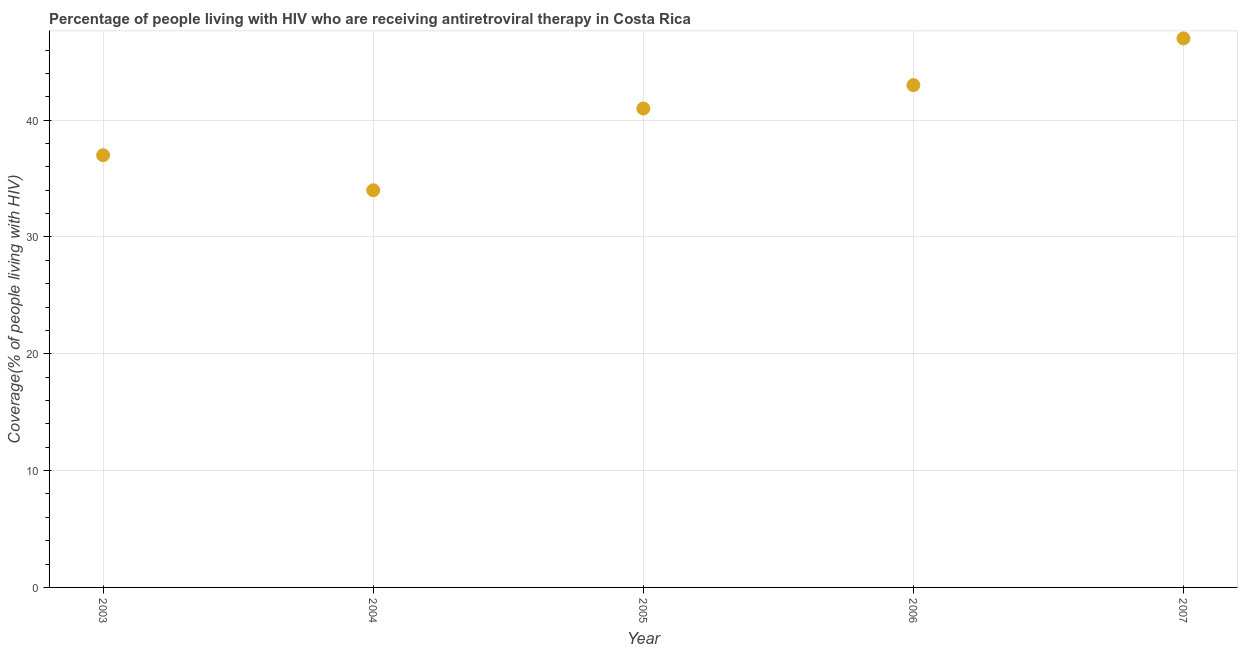What is the antiretroviral therapy coverage in 2004?
Offer a very short reply. 34. Across all years, what is the maximum antiretroviral therapy coverage?
Your answer should be very brief. 47. Across all years, what is the minimum antiretroviral therapy coverage?
Keep it short and to the point. 34. In which year was the antiretroviral therapy coverage maximum?
Offer a very short reply. 2007. In which year was the antiretroviral therapy coverage minimum?
Give a very brief answer. 2004. What is the sum of the antiretroviral therapy coverage?
Ensure brevity in your answer.  202. What is the difference between the antiretroviral therapy coverage in 2006 and 2007?
Keep it short and to the point. -4. What is the average antiretroviral therapy coverage per year?
Offer a terse response. 40.4. What is the ratio of the antiretroviral therapy coverage in 2006 to that in 2007?
Your response must be concise. 0.91. Is the antiretroviral therapy coverage in 2006 less than that in 2007?
Ensure brevity in your answer.  Yes. What is the difference between the highest and the lowest antiretroviral therapy coverage?
Your answer should be compact. 13. How many dotlines are there?
Keep it short and to the point. 1. What is the difference between two consecutive major ticks on the Y-axis?
Give a very brief answer. 10. Does the graph contain grids?
Keep it short and to the point. Yes. What is the title of the graph?
Offer a very short reply. Percentage of people living with HIV who are receiving antiretroviral therapy in Costa Rica. What is the label or title of the X-axis?
Your answer should be compact. Year. What is the label or title of the Y-axis?
Give a very brief answer. Coverage(% of people living with HIV). What is the Coverage(% of people living with HIV) in 2004?
Your answer should be compact. 34. What is the Coverage(% of people living with HIV) in 2005?
Provide a succinct answer. 41. What is the Coverage(% of people living with HIV) in 2007?
Provide a succinct answer. 47. What is the difference between the Coverage(% of people living with HIV) in 2003 and 2006?
Provide a succinct answer. -6. What is the difference between the Coverage(% of people living with HIV) in 2003 and 2007?
Provide a succinct answer. -10. What is the difference between the Coverage(% of people living with HIV) in 2004 and 2005?
Your answer should be very brief. -7. What is the difference between the Coverage(% of people living with HIV) in 2005 and 2007?
Your answer should be very brief. -6. What is the ratio of the Coverage(% of people living with HIV) in 2003 to that in 2004?
Your answer should be compact. 1.09. What is the ratio of the Coverage(% of people living with HIV) in 2003 to that in 2005?
Your response must be concise. 0.9. What is the ratio of the Coverage(% of people living with HIV) in 2003 to that in 2006?
Provide a succinct answer. 0.86. What is the ratio of the Coverage(% of people living with HIV) in 2003 to that in 2007?
Ensure brevity in your answer.  0.79. What is the ratio of the Coverage(% of people living with HIV) in 2004 to that in 2005?
Offer a terse response. 0.83. What is the ratio of the Coverage(% of people living with HIV) in 2004 to that in 2006?
Your answer should be compact. 0.79. What is the ratio of the Coverage(% of people living with HIV) in 2004 to that in 2007?
Your response must be concise. 0.72. What is the ratio of the Coverage(% of people living with HIV) in 2005 to that in 2006?
Ensure brevity in your answer.  0.95. What is the ratio of the Coverage(% of people living with HIV) in 2005 to that in 2007?
Offer a terse response. 0.87. What is the ratio of the Coverage(% of people living with HIV) in 2006 to that in 2007?
Offer a terse response. 0.92. 